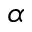<formula> <loc_0><loc_0><loc_500><loc_500>\alpha</formula> 